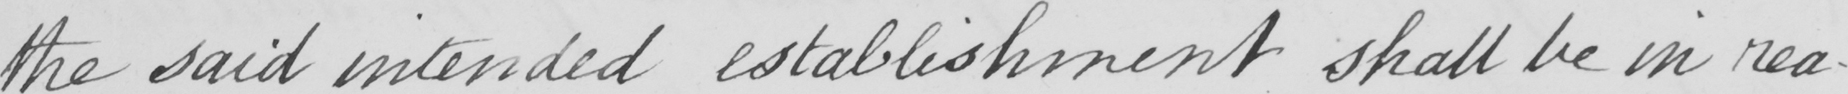Transcribe the text shown in this historical manuscript line. the said intended establishment shall be in rea- 